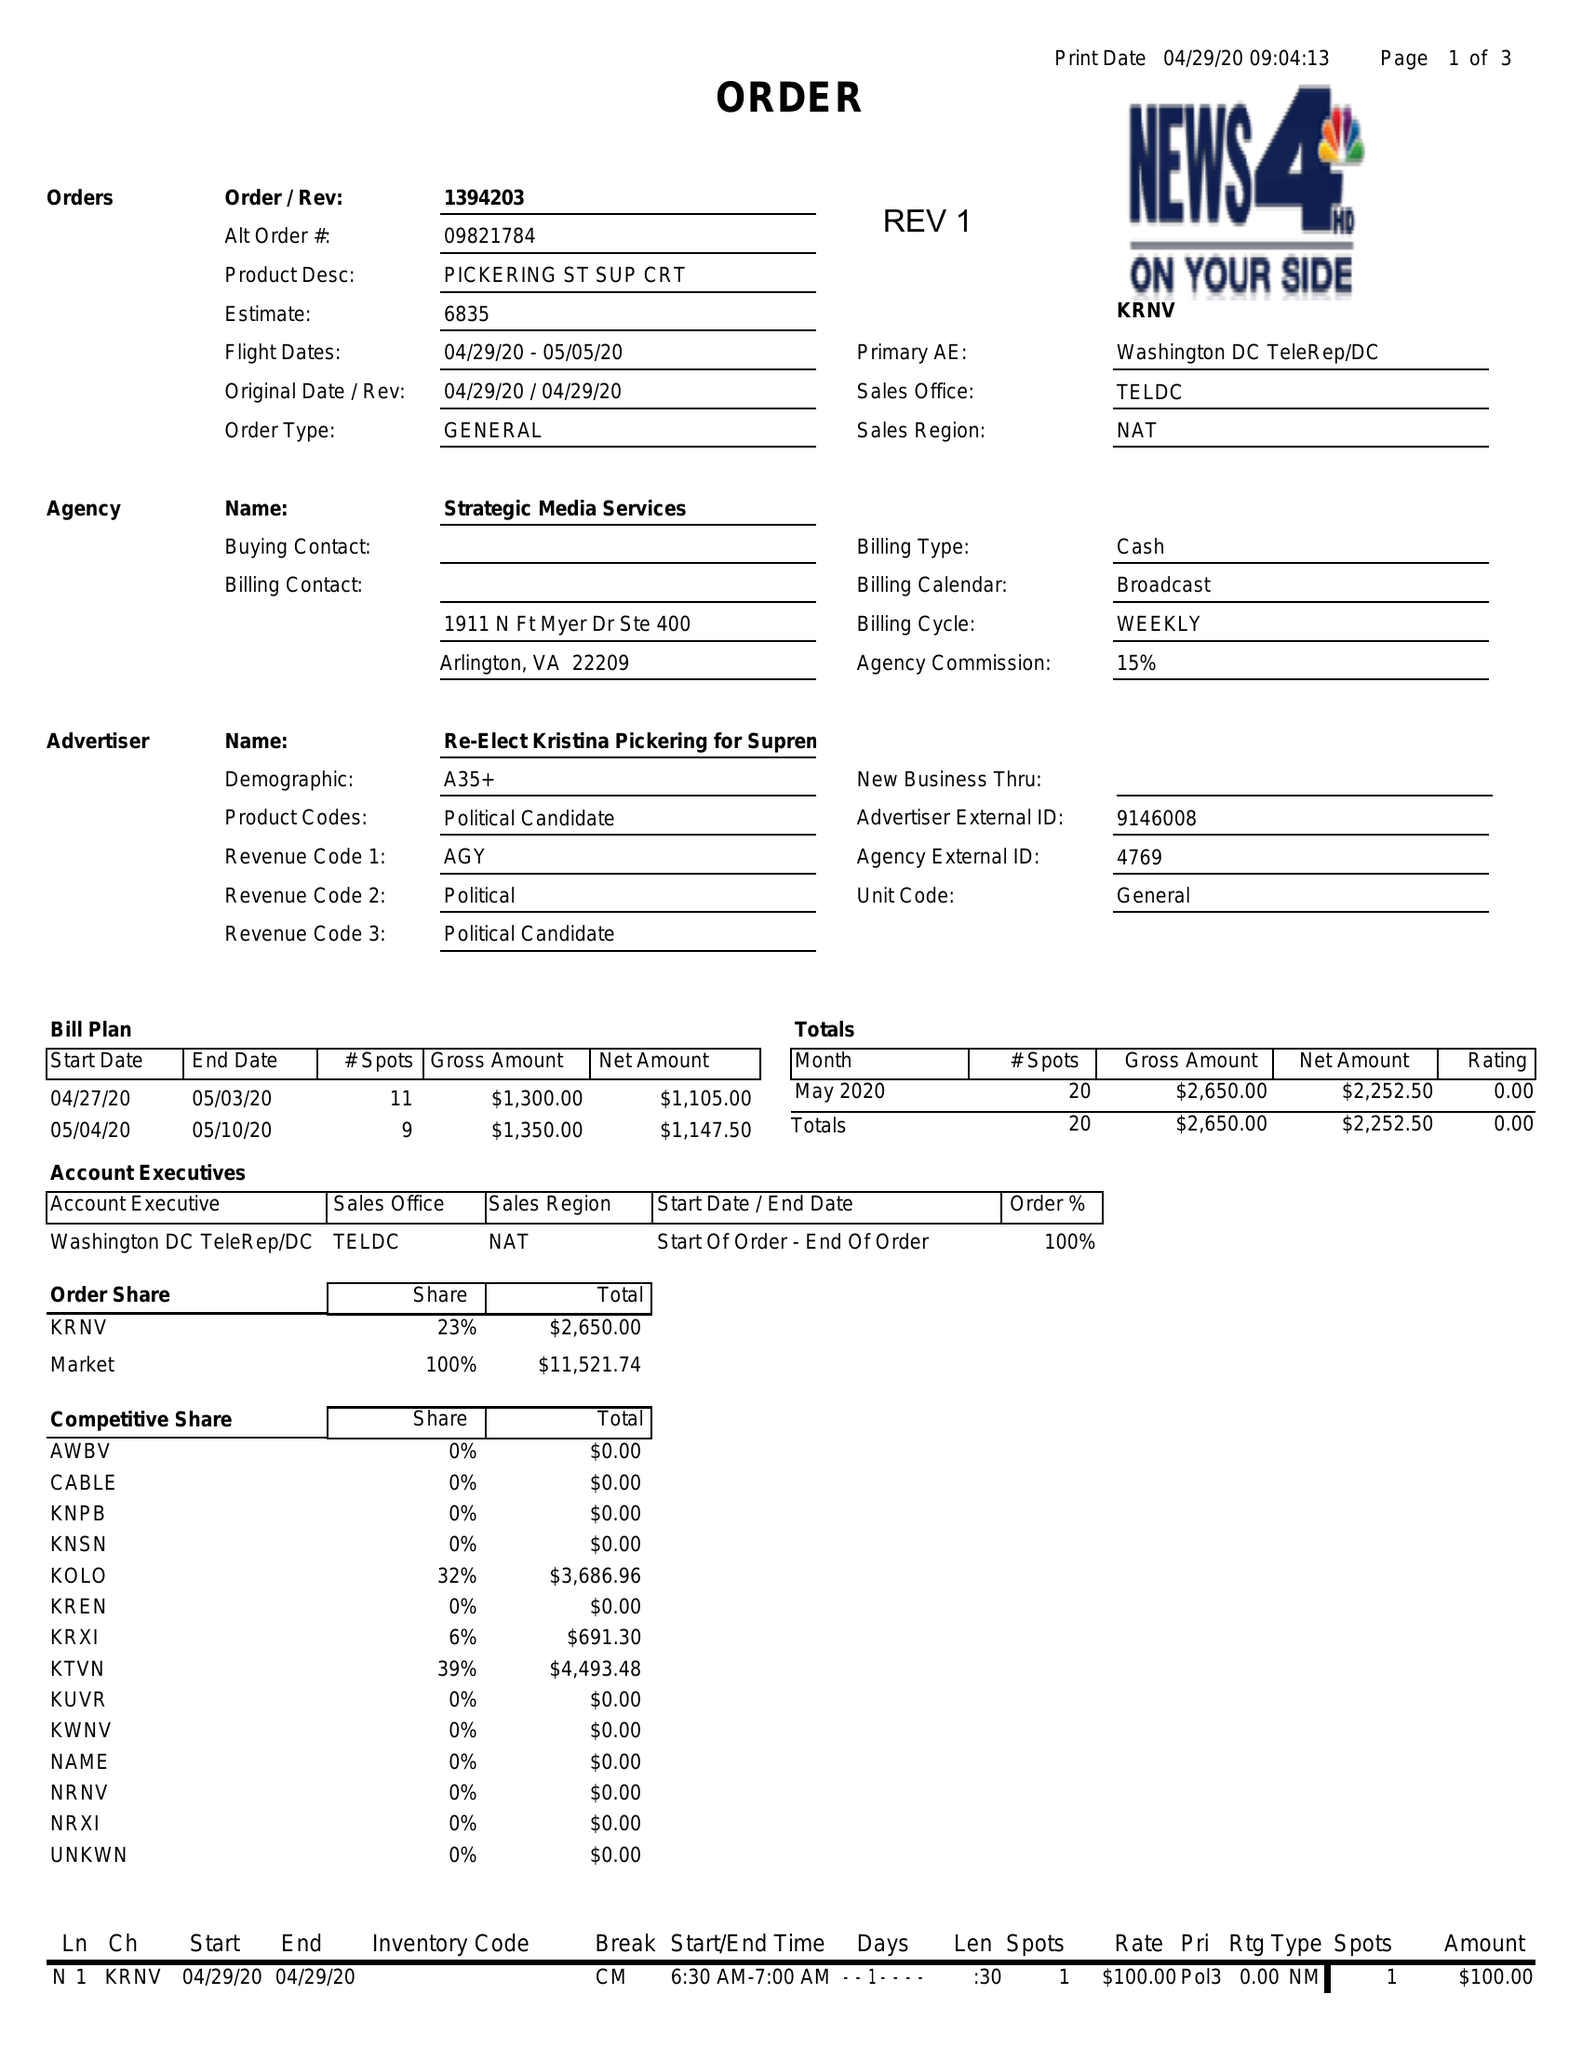What is the value for the advertiser?
Answer the question using a single word or phrase. RE-ELECT KRISTINA PICKERING FOR SUPREME COURT-R 